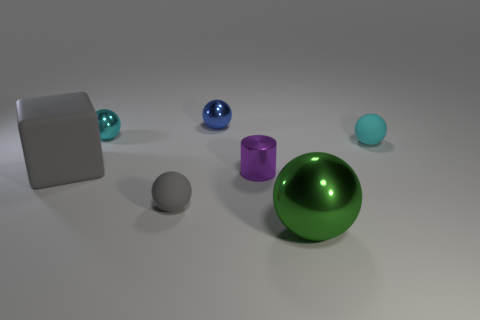Subtract all big green shiny balls. How many balls are left? 4 Add 1 gray cubes. How many objects exist? 8 Subtract all cyan blocks. How many cyan spheres are left? 2 Subtract 3 spheres. How many spheres are left? 2 Subtract all blue spheres. How many spheres are left? 4 Subtract all balls. How many objects are left? 2 Add 4 large green metal balls. How many large green metal balls are left? 5 Add 4 brown things. How many brown things exist? 4 Subtract 0 purple cubes. How many objects are left? 7 Subtract all cyan balls. Subtract all brown blocks. How many balls are left? 3 